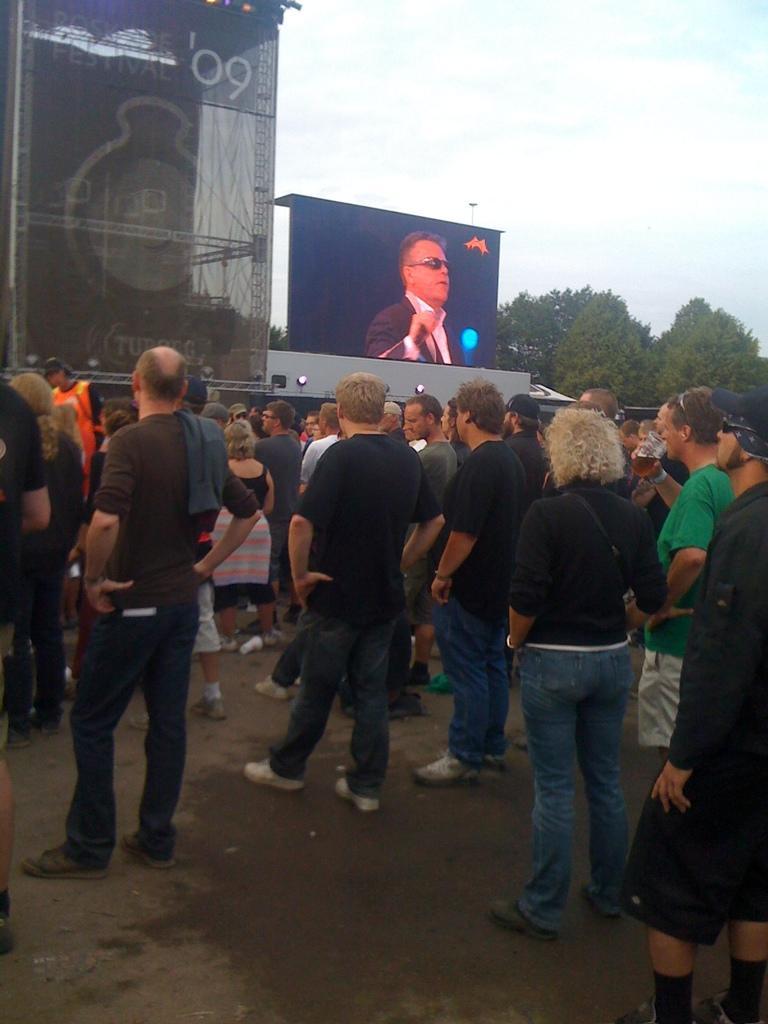Describe this image in one or two sentences. This picture shows so few people standing and we see a hoarding and we see a man holding a glass in his hand and drinking and we see a blue cloudy sky and trees. 